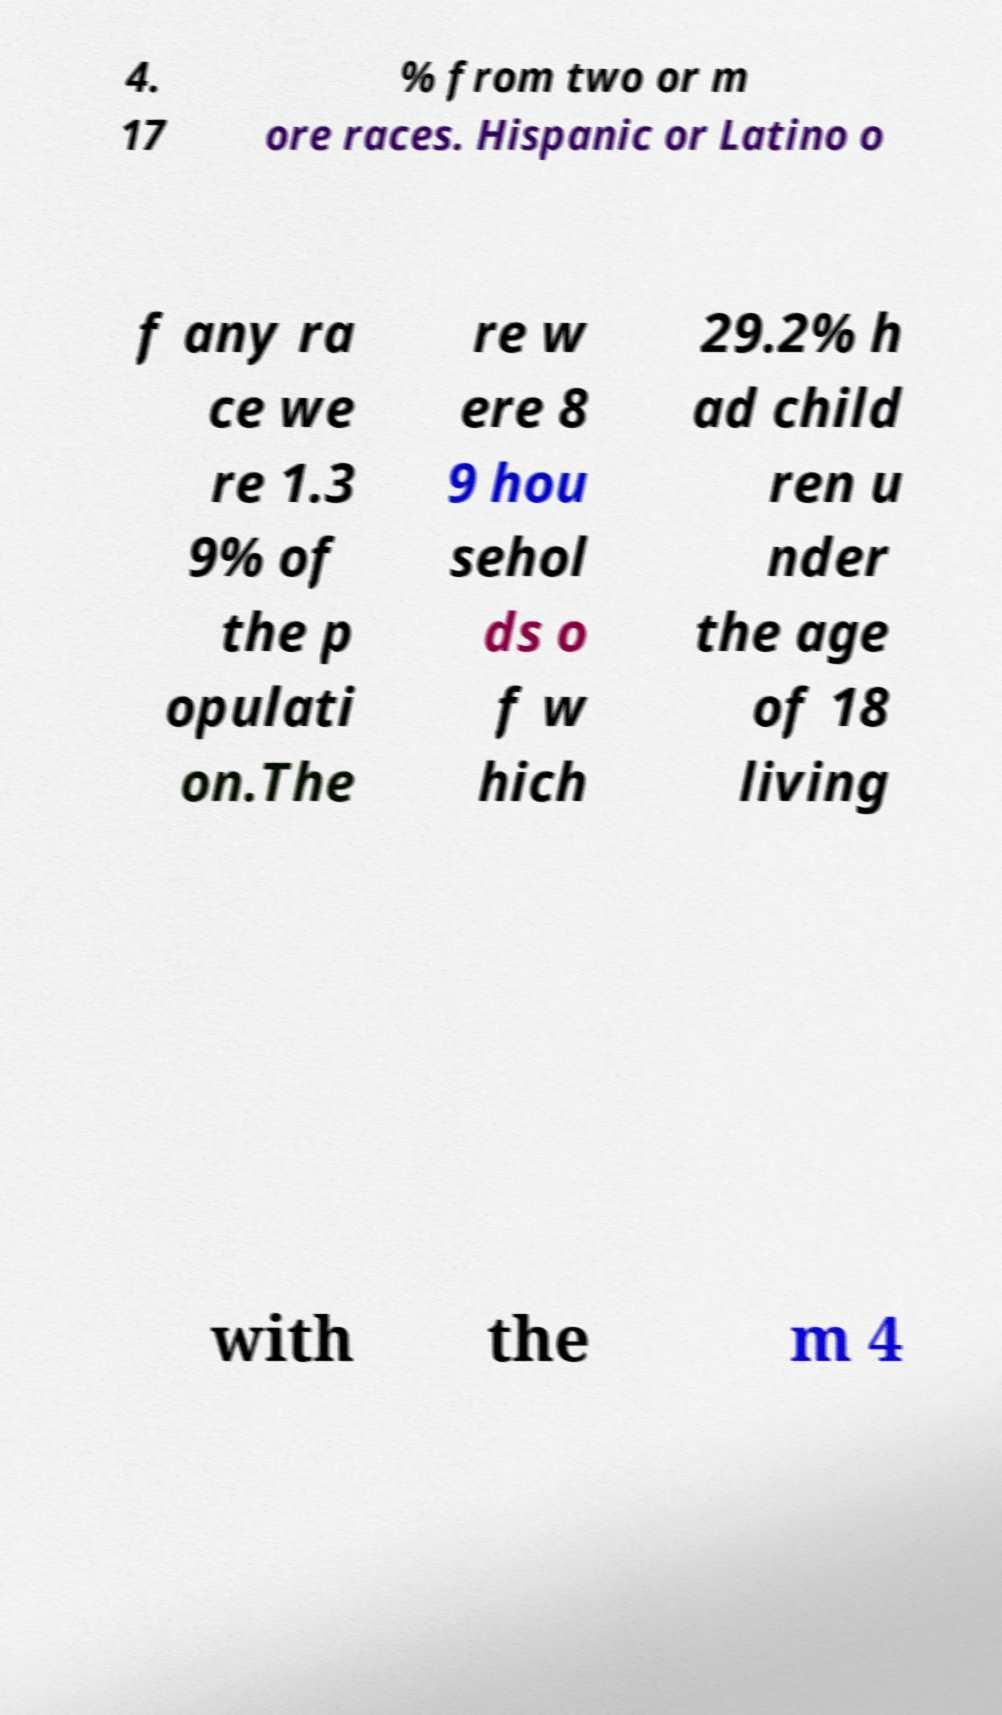Could you assist in decoding the text presented in this image and type it out clearly? 4. 17 % from two or m ore races. Hispanic or Latino o f any ra ce we re 1.3 9% of the p opulati on.The re w ere 8 9 hou sehol ds o f w hich 29.2% h ad child ren u nder the age of 18 living with the m 4 